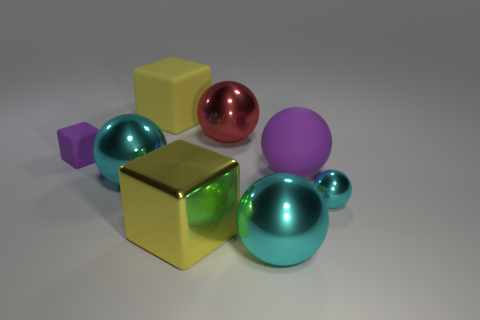How many cyan spheres must be subtracted to get 1 cyan spheres? 2 Subtract all tiny balls. How many balls are left? 4 Subtract all red cylinders. How many cyan balls are left? 3 Add 1 tiny objects. How many objects exist? 9 Subtract all red balls. How many balls are left? 4 Add 8 large yellow objects. How many large yellow objects are left? 10 Add 4 large yellow rubber blocks. How many large yellow rubber blocks exist? 5 Subtract 0 brown cylinders. How many objects are left? 8 Subtract all blocks. How many objects are left? 5 Subtract all cyan cubes. Subtract all purple cylinders. How many cubes are left? 3 